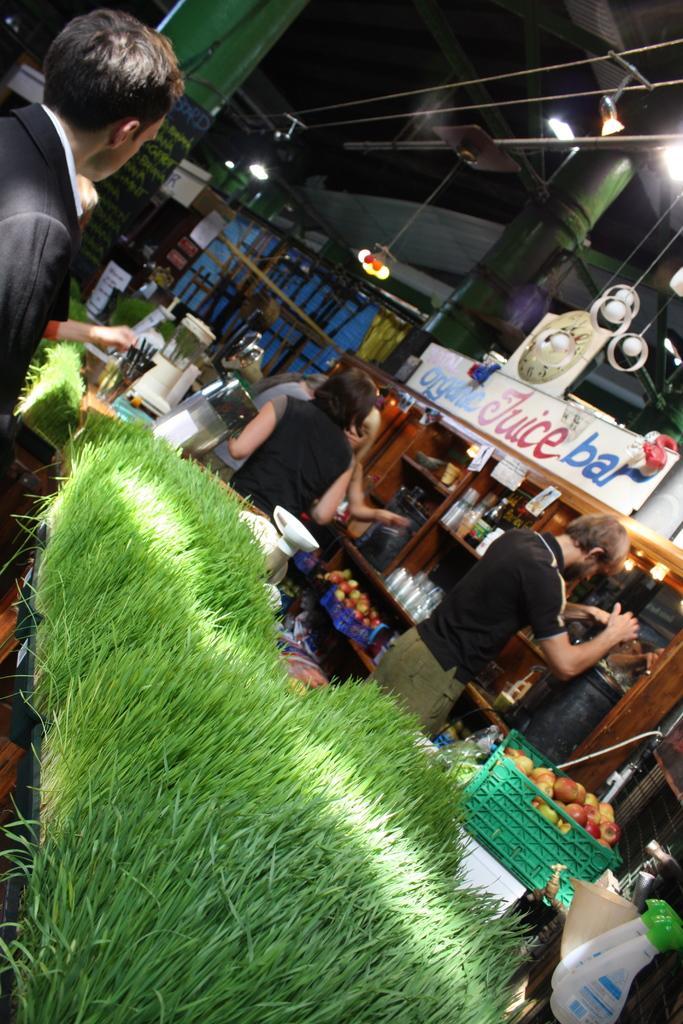Could you give a brief overview of what you see in this image? At the bottom of the picture, we see the grass. On the right side, we see a table on which a green color basket containing apples, glasses and bottles are placed. We see a mug and the white color bottles. In the middle, we see four people are standing. Beside that, we see a table on which some objects are placed. Beside them, we see a rack in which glasses, glass bottles and the baskets containing the fruits are placed. In the background, we see the wooden sticks, pillars and a wall. On the right side, we see a white color board with some text written on it. At the top, we see the ceiling and the lights. 